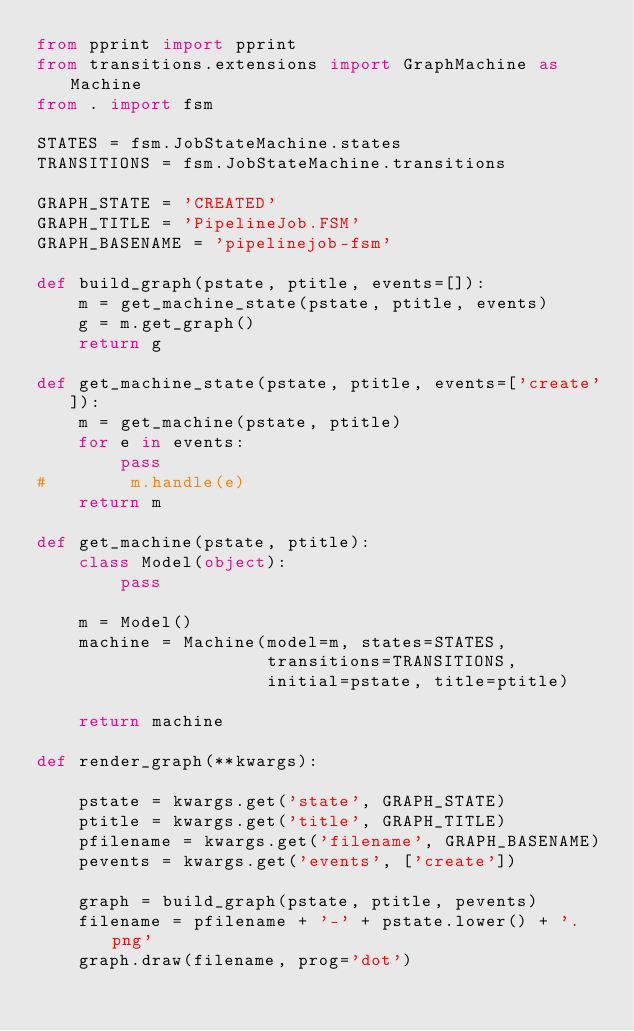Convert code to text. <code><loc_0><loc_0><loc_500><loc_500><_Python_>from pprint import pprint
from transitions.extensions import GraphMachine as Machine
from . import fsm

STATES = fsm.JobStateMachine.states
TRANSITIONS = fsm.JobStateMachine.transitions

GRAPH_STATE = 'CREATED'
GRAPH_TITLE = 'PipelineJob.FSM'
GRAPH_BASENAME = 'pipelinejob-fsm'

def build_graph(pstate, ptitle, events=[]):
    m = get_machine_state(pstate, ptitle, events)
    g = m.get_graph()
    return g

def get_machine_state(pstate, ptitle, events=['create']):
    m = get_machine(pstate, ptitle)
    for e in events:
        pass
#        m.handle(e)
    return m

def get_machine(pstate, ptitle):
    class Model(object):
        pass

    m = Model()
    machine = Machine(model=m, states=STATES,
                      transitions=TRANSITIONS,
                      initial=pstate, title=ptitle)

    return machine

def render_graph(**kwargs):

    pstate = kwargs.get('state', GRAPH_STATE)
    ptitle = kwargs.get('title', GRAPH_TITLE)
    pfilename = kwargs.get('filename', GRAPH_BASENAME)
    pevents = kwargs.get('events', ['create'])

    graph = build_graph(pstate, ptitle, pevents)
    filename = pfilename + '-' + pstate.lower() + '.png'
    graph.draw(filename, prog='dot')
</code> 